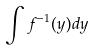<formula> <loc_0><loc_0><loc_500><loc_500>\int f ^ { - 1 } ( y ) d y</formula> 